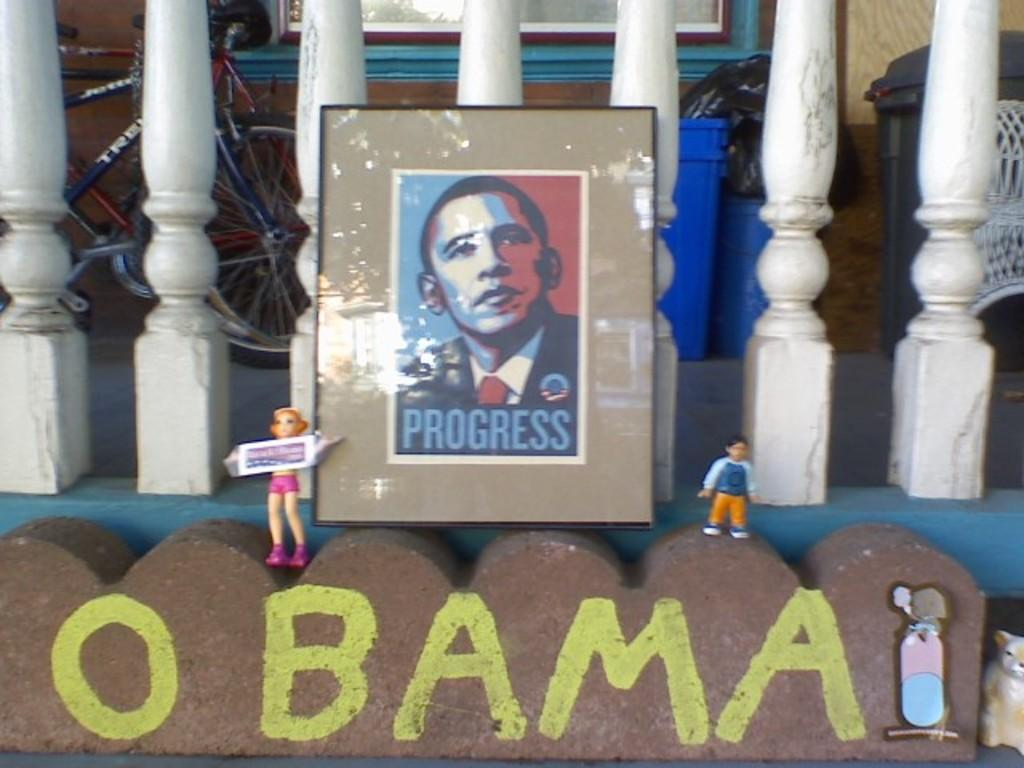How many bikes can be seen in the image? There are two bikes in the image. What other objects can be seen in the image besides the bikes? There are three dustbins and a photo visible in the image. Can you describe the toys in the image? There are a few toys on the wall in the image. What type of cave can be seen in the image? There is no cave present in the image. What kind of destruction can be observed in the image? There is no destruction present in the image. 